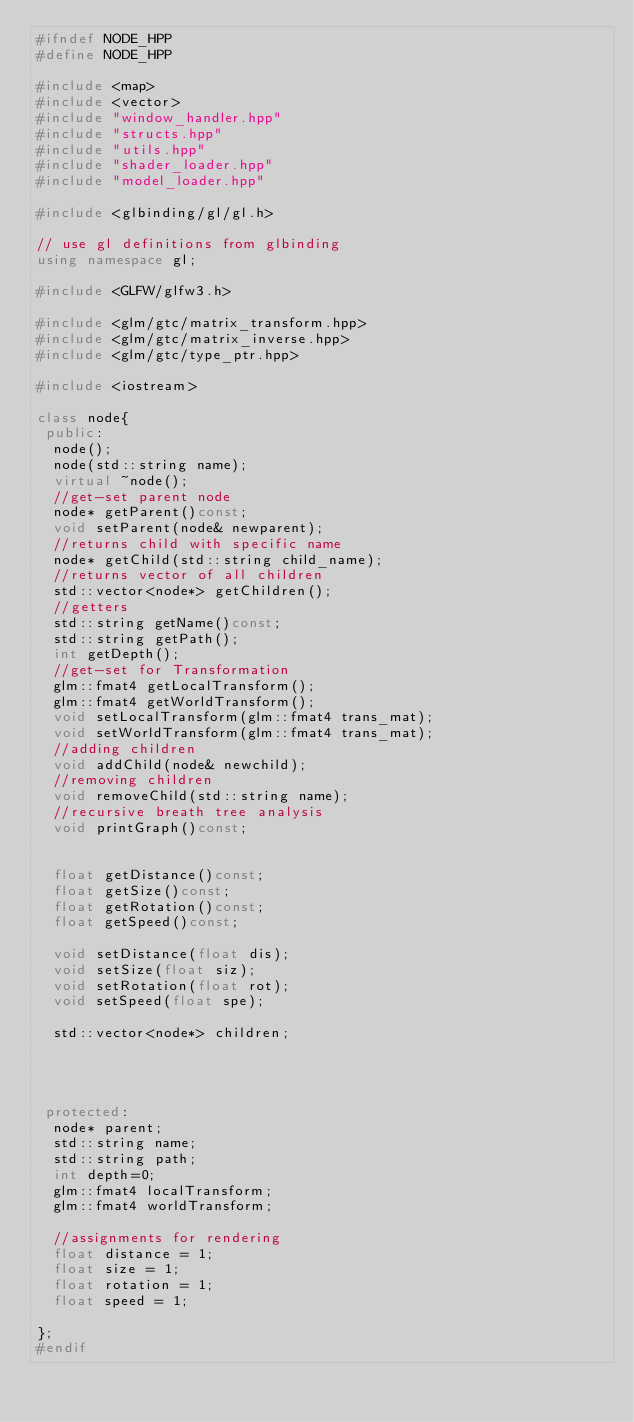Convert code to text. <code><loc_0><loc_0><loc_500><loc_500><_C++_>#ifndef NODE_HPP
#define NODE_HPP

#include <map>
#include <vector>
#include "window_handler.hpp"
#include "structs.hpp"
#include "utils.hpp"
#include "shader_loader.hpp"
#include "model_loader.hpp"

#include <glbinding/gl/gl.h>

// use gl definitions from glbinding 
using namespace gl;

#include <GLFW/glfw3.h>

#include <glm/gtc/matrix_transform.hpp>
#include <glm/gtc/matrix_inverse.hpp>
#include <glm/gtc/type_ptr.hpp>

#include <iostream>

class node{
 public:
	node();
	node(std::string name);
	virtual ~node();
	//get-set parent node
	node* getParent()const;
	void setParent(node& newparent);
	//returns child with specific name
	node* getChild(std::string child_name);
	//returns vector of all children
	std::vector<node*> getChildren();
	//getters
	std::string getName()const;
	std::string getPath();
	int getDepth();
	//get-set for Transformation
	glm::fmat4 getLocalTransform();
	glm::fmat4 getWorldTransform();
	void setLocalTransform(glm::fmat4 trans_mat);
	void setWorldTransform(glm::fmat4 trans_mat);
	//adding children
	void addChild(node& newchild);
	//removing children
	void removeChild(std::string name);
	//recursive breath tree analysis
	void printGraph()const;


	float getDistance()const;
	float getSize()const;
	float getRotation()const;
	float getSpeed()const;

	void setDistance(float dis);
	void setSize(float siz);
	void setRotation(float rot);
	void setSpeed(float spe);

 	std::vector<node*> children;


	

 protected: 	
 	node* parent; 	
 	std::string name;
 	std::string path;
 	int depth=0;
 	glm::fmat4 localTransform;
 	glm::fmat4 worldTransform;

 	//assignments for rendering 
	float distance = 1;
	float size = 1;
	float rotation = 1;
	float speed = 1;

};
#endif</code> 